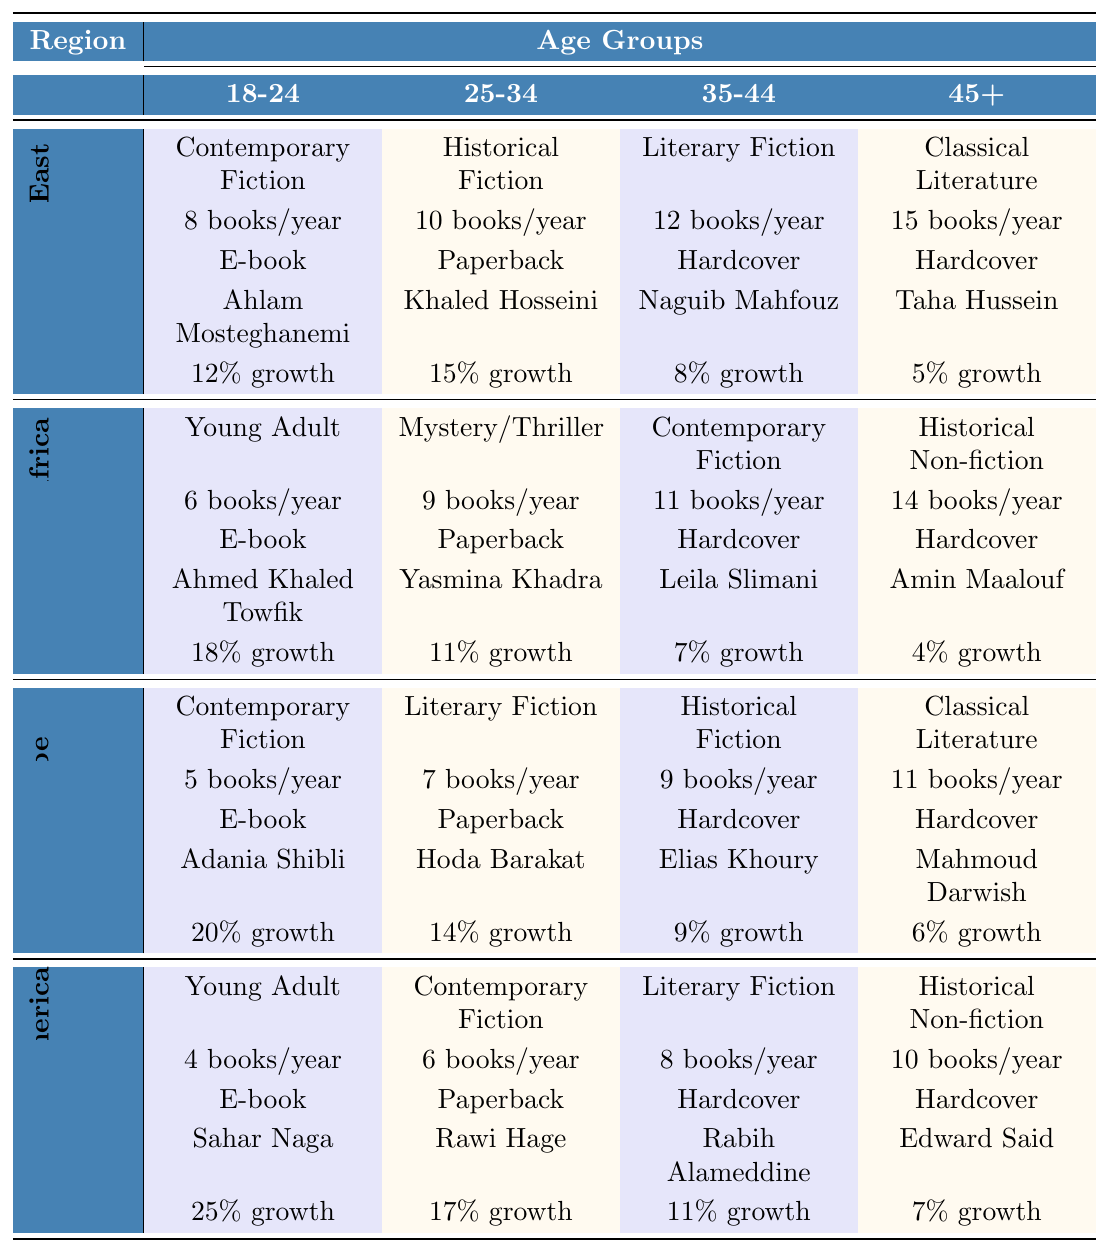What is the top-selling genre among readers aged 18-24 in the Middle East? According to the table, the top-selling genre for the 18-24 age group in the Middle East is "Contemporary Fiction."
Answer: Contemporary Fiction Which age group has the highest average number of books read per year in North Africa? In North Africa, the 45+ age group has the highest average number of books read per year at 14 books.
Answer: 45+ What is the preferred format for readers aged 35-44 in Europe? The preferred format for readers aged 35-44 in Europe is "Hardcover."
Answer: Hardcover Which author is the most popular among 25-34-year-olds in North America? The most popular author for the 25-34 age group in North America is "Rawi Hage."
Answer: Rawi Hage Is the sales growth for 45+ readers in the Middle East higher than that of North Africa? The sales growth for the 45+ age group in the Middle East is 5%, while in North Africa, it is 4%. Since 5% is higher than 4%, the statement is true.
Answer: Yes What is the average number of books read per year across all age groups in Europe? To find the average, we sum the average books read for each age group (5 + 7 + 9 + 11) = 32 and divide by the number of age groups (4). Thus, 32/4 = 8.
Answer: 8 Which region shows the highest sales growth for the 18-24 age group? In the 18-24 age group, North America shows the highest sales growth at 25%, compared to other regions.
Answer: North America Does the average number of books read per year for 35-44-year-olds in North Africa exceed that of the same age group in Europe? In North Africa, 35-44-year-olds read 11 books per year, while in Europe, they read 9 books per year. Since 11 is greater than 9, the statement is true.
Answer: Yes What is the difference in average books read per year between the 18-24 and 25-34 age groups in the Middle East? The 18-24 age group reads an average of 8 books per year while the 25-34 age group reads 10 books. The difference is 10 - 8 = 2 books.
Answer: 2 In which region and age group do readers prefer E-books most? In North America, readers aged 18-24 prefer E-books the most, as indicated in the table.
Answer: North America, 18-24 